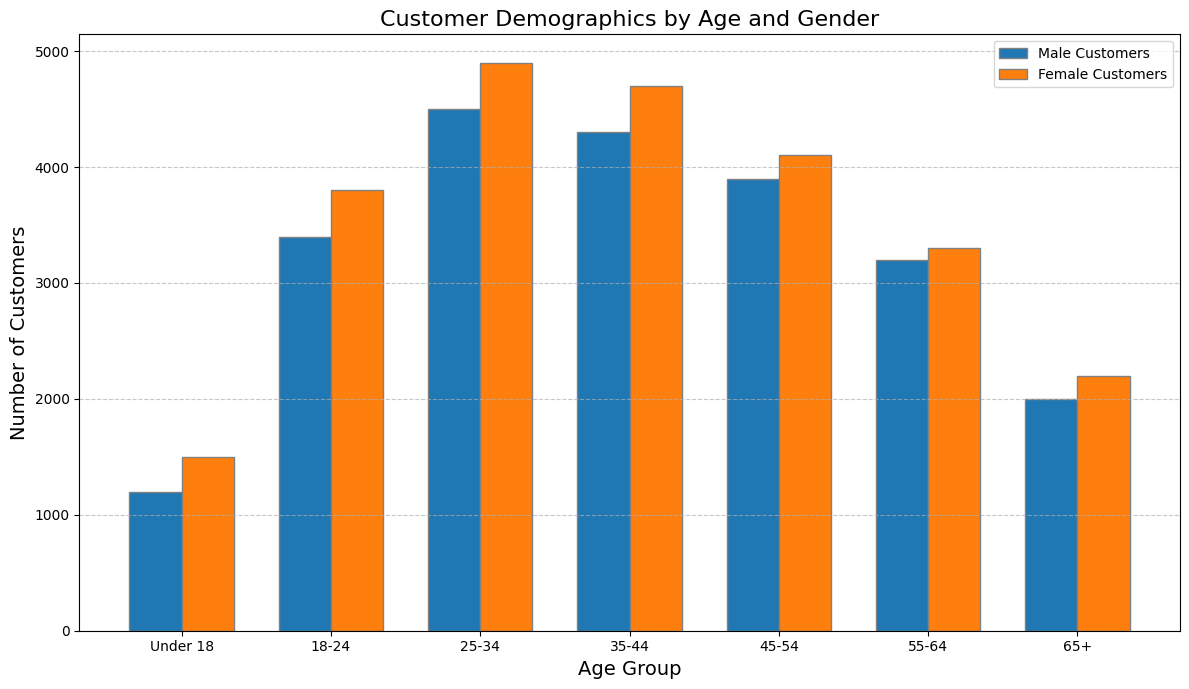Which age group has the highest number of customers overall? To find the age group with the highest number of customers, sum the number of male and female customers for each age group and compare. The 25-34 age group has 4500 male and 4900 female customers, totaling 9400, which is the highest overall.
Answer: 25-34 In the 18-24 age group, who visits the store more, males or females? Compare the number of male and female customers in the 18-24 age group. There are 3400 male and 3800 female customers, so females visit more.
Answer: Females How many more female customers are there in the 25-34 age group compared to male customers in the same group? Subtract the number of male customers from the number of female customers in the 25-34 age group: 4900 - 4500 = 400.
Answer: 400 Which age group has the smallest gender difference in the number of customers? Calculate the difference between male and female customers for each age group. The 55-64 age group has 3300 female and 3200 male customers, with a difference of 100, which is the smallest.
Answer: 55-64 How many customers are there in the 65+ age group in total? Sum the number of male and female customers in the 65+ age group: 2000 (male) + 2200 (female) = 4200.
Answer: 4200 What is the total number of male customers in the 35-44 and 45-54 age groups combined? Add the number of male customers in the 35-44 and 45-54 age groups: 4300 (35-44) + 3900 (45-54) = 8200.
Answer: 8200 Which age group has the highest number of male customers? Compare the number of male customers across different age groups. The 25-34 age group has 4500 male customers, which is the highest.
Answer: 25-34 Are there more customers in the 55-64 age group or the Under 18 age group? Compare the total number of customers in these two age groups. For the Under 18 group, 1200 (male) + 1500 (female) = 2700. For the 55-64 group, 3200 (male) + 3300 (female) = 6500. The 55-64 age group has more.
Answer: 55-64 By how much does the number of female customers in the 45-54 age group exceed the number of male customers in the same group? Subtract the number of male customers from the number of female customers in the 45-54 age group: 4100 - 3900 = 200.
Answer: 200 